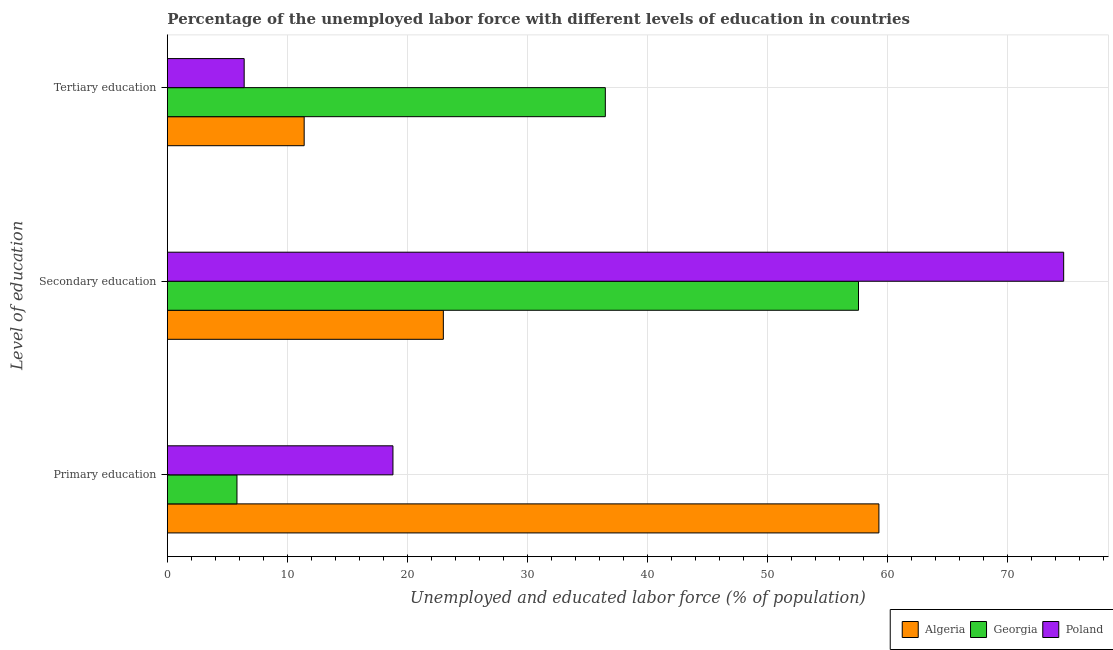How many different coloured bars are there?
Provide a succinct answer. 3. How many groups of bars are there?
Give a very brief answer. 3. Are the number of bars per tick equal to the number of legend labels?
Your response must be concise. Yes. Are the number of bars on each tick of the Y-axis equal?
Your answer should be very brief. Yes. How many bars are there on the 3rd tick from the top?
Make the answer very short. 3. How many bars are there on the 3rd tick from the bottom?
Keep it short and to the point. 3. What is the label of the 2nd group of bars from the top?
Your response must be concise. Secondary education. What is the percentage of labor force who received primary education in Georgia?
Keep it short and to the point. 5.8. Across all countries, what is the maximum percentage of labor force who received primary education?
Keep it short and to the point. 59.3. Across all countries, what is the minimum percentage of labor force who received tertiary education?
Make the answer very short. 6.4. In which country was the percentage of labor force who received tertiary education maximum?
Your answer should be very brief. Georgia. In which country was the percentage of labor force who received tertiary education minimum?
Your answer should be compact. Poland. What is the total percentage of labor force who received tertiary education in the graph?
Provide a succinct answer. 54.3. What is the difference between the percentage of labor force who received primary education in Algeria and that in Georgia?
Keep it short and to the point. 53.5. What is the difference between the percentage of labor force who received tertiary education in Poland and the percentage of labor force who received primary education in Algeria?
Provide a short and direct response. -52.9. What is the average percentage of labor force who received secondary education per country?
Give a very brief answer. 51.77. What is the difference between the percentage of labor force who received tertiary education and percentage of labor force who received secondary education in Georgia?
Provide a short and direct response. -21.1. In how many countries, is the percentage of labor force who received tertiary education greater than 24 %?
Provide a succinct answer. 1. What is the ratio of the percentage of labor force who received primary education in Poland to that in Georgia?
Ensure brevity in your answer.  3.24. Is the percentage of labor force who received tertiary education in Algeria less than that in Poland?
Offer a terse response. No. What is the difference between the highest and the second highest percentage of labor force who received secondary education?
Provide a short and direct response. 17.1. What is the difference between the highest and the lowest percentage of labor force who received secondary education?
Ensure brevity in your answer.  51.7. In how many countries, is the percentage of labor force who received secondary education greater than the average percentage of labor force who received secondary education taken over all countries?
Provide a succinct answer. 2. How many bars are there?
Make the answer very short. 9. How many countries are there in the graph?
Keep it short and to the point. 3. What is the difference between two consecutive major ticks on the X-axis?
Your answer should be compact. 10. Does the graph contain any zero values?
Provide a succinct answer. No. Does the graph contain grids?
Offer a terse response. Yes. Where does the legend appear in the graph?
Give a very brief answer. Bottom right. What is the title of the graph?
Offer a very short reply. Percentage of the unemployed labor force with different levels of education in countries. What is the label or title of the X-axis?
Your answer should be compact. Unemployed and educated labor force (% of population). What is the label or title of the Y-axis?
Your answer should be very brief. Level of education. What is the Unemployed and educated labor force (% of population) in Algeria in Primary education?
Your answer should be very brief. 59.3. What is the Unemployed and educated labor force (% of population) in Georgia in Primary education?
Your response must be concise. 5.8. What is the Unemployed and educated labor force (% of population) of Poland in Primary education?
Offer a terse response. 18.8. What is the Unemployed and educated labor force (% of population) in Algeria in Secondary education?
Make the answer very short. 23. What is the Unemployed and educated labor force (% of population) in Georgia in Secondary education?
Your answer should be compact. 57.6. What is the Unemployed and educated labor force (% of population) in Poland in Secondary education?
Offer a terse response. 74.7. What is the Unemployed and educated labor force (% of population) in Algeria in Tertiary education?
Keep it short and to the point. 11.4. What is the Unemployed and educated labor force (% of population) in Georgia in Tertiary education?
Offer a very short reply. 36.5. What is the Unemployed and educated labor force (% of population) of Poland in Tertiary education?
Provide a succinct answer. 6.4. Across all Level of education, what is the maximum Unemployed and educated labor force (% of population) in Algeria?
Your response must be concise. 59.3. Across all Level of education, what is the maximum Unemployed and educated labor force (% of population) in Georgia?
Keep it short and to the point. 57.6. Across all Level of education, what is the maximum Unemployed and educated labor force (% of population) of Poland?
Keep it short and to the point. 74.7. Across all Level of education, what is the minimum Unemployed and educated labor force (% of population) in Algeria?
Your answer should be very brief. 11.4. Across all Level of education, what is the minimum Unemployed and educated labor force (% of population) of Georgia?
Provide a succinct answer. 5.8. Across all Level of education, what is the minimum Unemployed and educated labor force (% of population) of Poland?
Keep it short and to the point. 6.4. What is the total Unemployed and educated labor force (% of population) in Algeria in the graph?
Provide a short and direct response. 93.7. What is the total Unemployed and educated labor force (% of population) of Georgia in the graph?
Provide a short and direct response. 99.9. What is the total Unemployed and educated labor force (% of population) in Poland in the graph?
Offer a very short reply. 99.9. What is the difference between the Unemployed and educated labor force (% of population) of Algeria in Primary education and that in Secondary education?
Offer a terse response. 36.3. What is the difference between the Unemployed and educated labor force (% of population) of Georgia in Primary education and that in Secondary education?
Your answer should be compact. -51.8. What is the difference between the Unemployed and educated labor force (% of population) of Poland in Primary education and that in Secondary education?
Your answer should be very brief. -55.9. What is the difference between the Unemployed and educated labor force (% of population) of Algeria in Primary education and that in Tertiary education?
Your answer should be very brief. 47.9. What is the difference between the Unemployed and educated labor force (% of population) in Georgia in Primary education and that in Tertiary education?
Offer a terse response. -30.7. What is the difference between the Unemployed and educated labor force (% of population) in Poland in Primary education and that in Tertiary education?
Make the answer very short. 12.4. What is the difference between the Unemployed and educated labor force (% of population) of Georgia in Secondary education and that in Tertiary education?
Keep it short and to the point. 21.1. What is the difference between the Unemployed and educated labor force (% of population) in Poland in Secondary education and that in Tertiary education?
Your answer should be very brief. 68.3. What is the difference between the Unemployed and educated labor force (% of population) in Algeria in Primary education and the Unemployed and educated labor force (% of population) in Poland in Secondary education?
Ensure brevity in your answer.  -15.4. What is the difference between the Unemployed and educated labor force (% of population) in Georgia in Primary education and the Unemployed and educated labor force (% of population) in Poland in Secondary education?
Provide a succinct answer. -68.9. What is the difference between the Unemployed and educated labor force (% of population) in Algeria in Primary education and the Unemployed and educated labor force (% of population) in Georgia in Tertiary education?
Your answer should be compact. 22.8. What is the difference between the Unemployed and educated labor force (% of population) of Algeria in Primary education and the Unemployed and educated labor force (% of population) of Poland in Tertiary education?
Offer a very short reply. 52.9. What is the difference between the Unemployed and educated labor force (% of population) in Georgia in Primary education and the Unemployed and educated labor force (% of population) in Poland in Tertiary education?
Give a very brief answer. -0.6. What is the difference between the Unemployed and educated labor force (% of population) of Georgia in Secondary education and the Unemployed and educated labor force (% of population) of Poland in Tertiary education?
Keep it short and to the point. 51.2. What is the average Unemployed and educated labor force (% of population) of Algeria per Level of education?
Your answer should be compact. 31.23. What is the average Unemployed and educated labor force (% of population) in Georgia per Level of education?
Your answer should be compact. 33.3. What is the average Unemployed and educated labor force (% of population) of Poland per Level of education?
Provide a short and direct response. 33.3. What is the difference between the Unemployed and educated labor force (% of population) in Algeria and Unemployed and educated labor force (% of population) in Georgia in Primary education?
Offer a terse response. 53.5. What is the difference between the Unemployed and educated labor force (% of population) of Algeria and Unemployed and educated labor force (% of population) of Poland in Primary education?
Provide a short and direct response. 40.5. What is the difference between the Unemployed and educated labor force (% of population) of Algeria and Unemployed and educated labor force (% of population) of Georgia in Secondary education?
Your answer should be compact. -34.6. What is the difference between the Unemployed and educated labor force (% of population) of Algeria and Unemployed and educated labor force (% of population) of Poland in Secondary education?
Give a very brief answer. -51.7. What is the difference between the Unemployed and educated labor force (% of population) in Georgia and Unemployed and educated labor force (% of population) in Poland in Secondary education?
Keep it short and to the point. -17.1. What is the difference between the Unemployed and educated labor force (% of population) of Algeria and Unemployed and educated labor force (% of population) of Georgia in Tertiary education?
Ensure brevity in your answer.  -25.1. What is the difference between the Unemployed and educated labor force (% of population) of Algeria and Unemployed and educated labor force (% of population) of Poland in Tertiary education?
Keep it short and to the point. 5. What is the difference between the Unemployed and educated labor force (% of population) of Georgia and Unemployed and educated labor force (% of population) of Poland in Tertiary education?
Keep it short and to the point. 30.1. What is the ratio of the Unemployed and educated labor force (% of population) in Algeria in Primary education to that in Secondary education?
Make the answer very short. 2.58. What is the ratio of the Unemployed and educated labor force (% of population) of Georgia in Primary education to that in Secondary education?
Your answer should be very brief. 0.1. What is the ratio of the Unemployed and educated labor force (% of population) in Poland in Primary education to that in Secondary education?
Your response must be concise. 0.25. What is the ratio of the Unemployed and educated labor force (% of population) of Algeria in Primary education to that in Tertiary education?
Your answer should be compact. 5.2. What is the ratio of the Unemployed and educated labor force (% of population) in Georgia in Primary education to that in Tertiary education?
Ensure brevity in your answer.  0.16. What is the ratio of the Unemployed and educated labor force (% of population) in Poland in Primary education to that in Tertiary education?
Ensure brevity in your answer.  2.94. What is the ratio of the Unemployed and educated labor force (% of population) of Algeria in Secondary education to that in Tertiary education?
Your response must be concise. 2.02. What is the ratio of the Unemployed and educated labor force (% of population) in Georgia in Secondary education to that in Tertiary education?
Keep it short and to the point. 1.58. What is the ratio of the Unemployed and educated labor force (% of population) in Poland in Secondary education to that in Tertiary education?
Ensure brevity in your answer.  11.67. What is the difference between the highest and the second highest Unemployed and educated labor force (% of population) in Algeria?
Your answer should be very brief. 36.3. What is the difference between the highest and the second highest Unemployed and educated labor force (% of population) of Georgia?
Offer a very short reply. 21.1. What is the difference between the highest and the second highest Unemployed and educated labor force (% of population) in Poland?
Make the answer very short. 55.9. What is the difference between the highest and the lowest Unemployed and educated labor force (% of population) in Algeria?
Your answer should be compact. 47.9. What is the difference between the highest and the lowest Unemployed and educated labor force (% of population) of Georgia?
Your answer should be compact. 51.8. What is the difference between the highest and the lowest Unemployed and educated labor force (% of population) in Poland?
Your response must be concise. 68.3. 